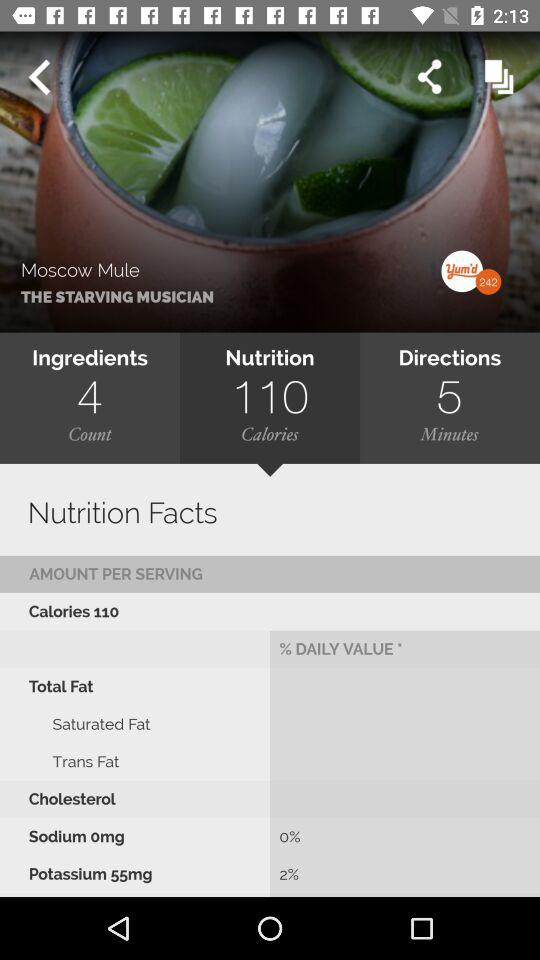How many ingredients are required? The number of required ingredients is 4. 